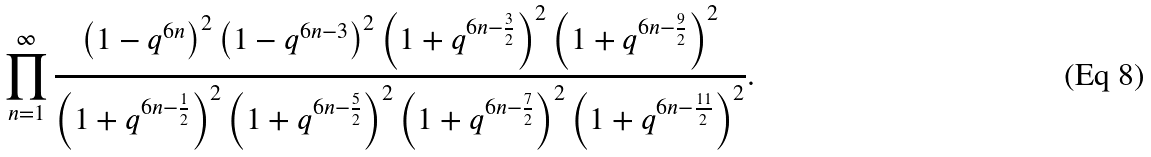Convert formula to latex. <formula><loc_0><loc_0><loc_500><loc_500>\prod _ { n = 1 } ^ { \infty } \frac { \left ( 1 - q ^ { 6 n } \right ) ^ { 2 } \left ( 1 - q ^ { 6 n - 3 } \right ) ^ { 2 } \left ( 1 + q ^ { 6 n - \frac { 3 } { 2 } } \right ) ^ { 2 } \left ( 1 + q ^ { 6 n - \frac { 9 } { 2 } } \right ) ^ { 2 } } { \left ( 1 + q ^ { 6 n - \frac { 1 } { 2 } } \right ) ^ { 2 } \left ( 1 + q ^ { 6 n - \frac { 5 } { 2 } } \right ) ^ { 2 } \left ( 1 + q ^ { 6 n - \frac { 7 } { 2 } } \right ) ^ { 2 } \left ( 1 + q ^ { 6 n - \frac { 1 1 } { 2 } } \right ) ^ { 2 } } .</formula> 